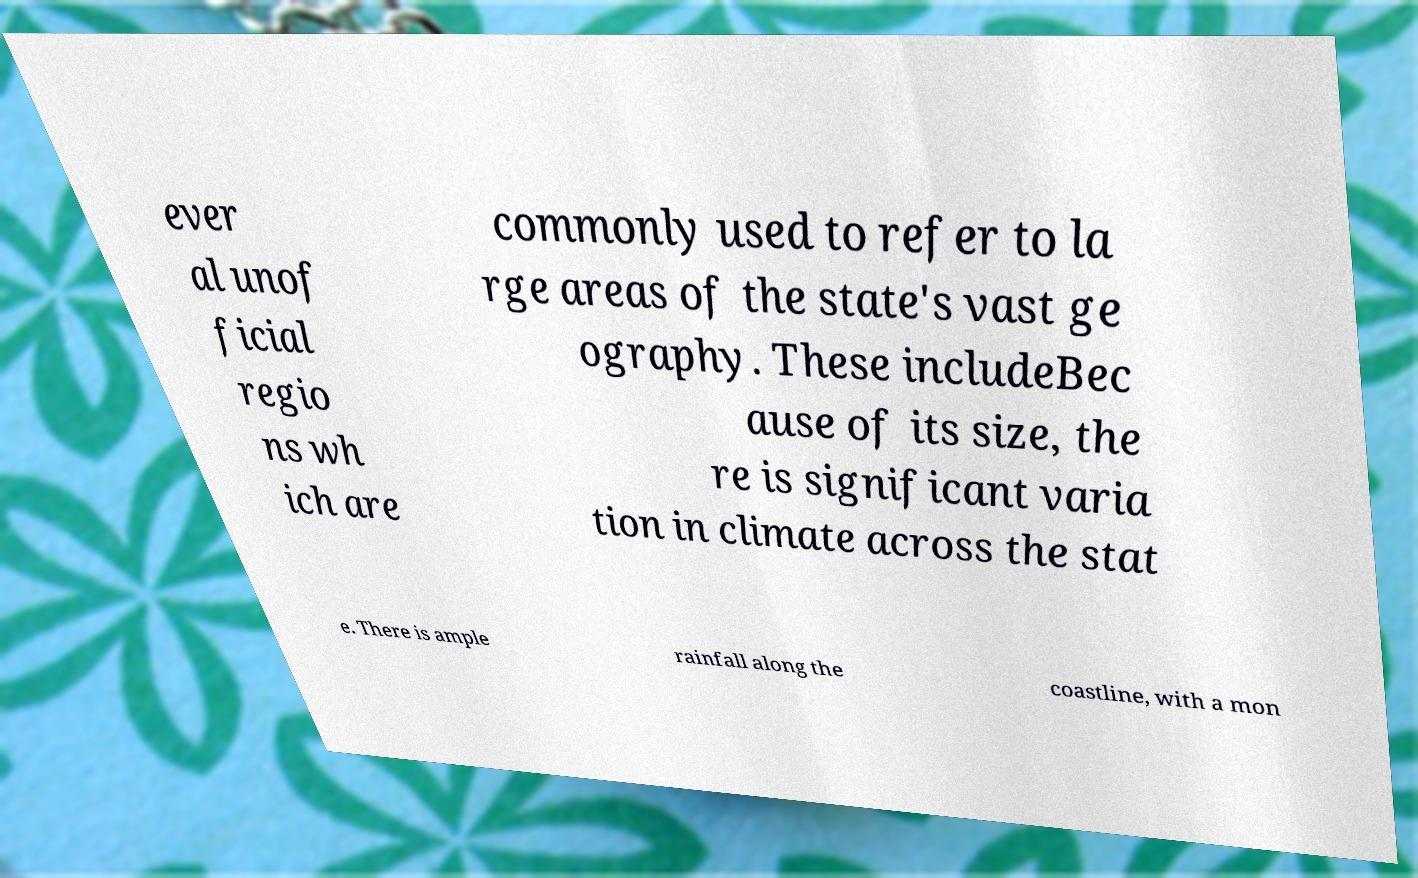Please read and relay the text visible in this image. What does it say? ever al unof ficial regio ns wh ich are commonly used to refer to la rge areas of the state's vast ge ography. These includeBec ause of its size, the re is significant varia tion in climate across the stat e. There is ample rainfall along the coastline, with a mon 